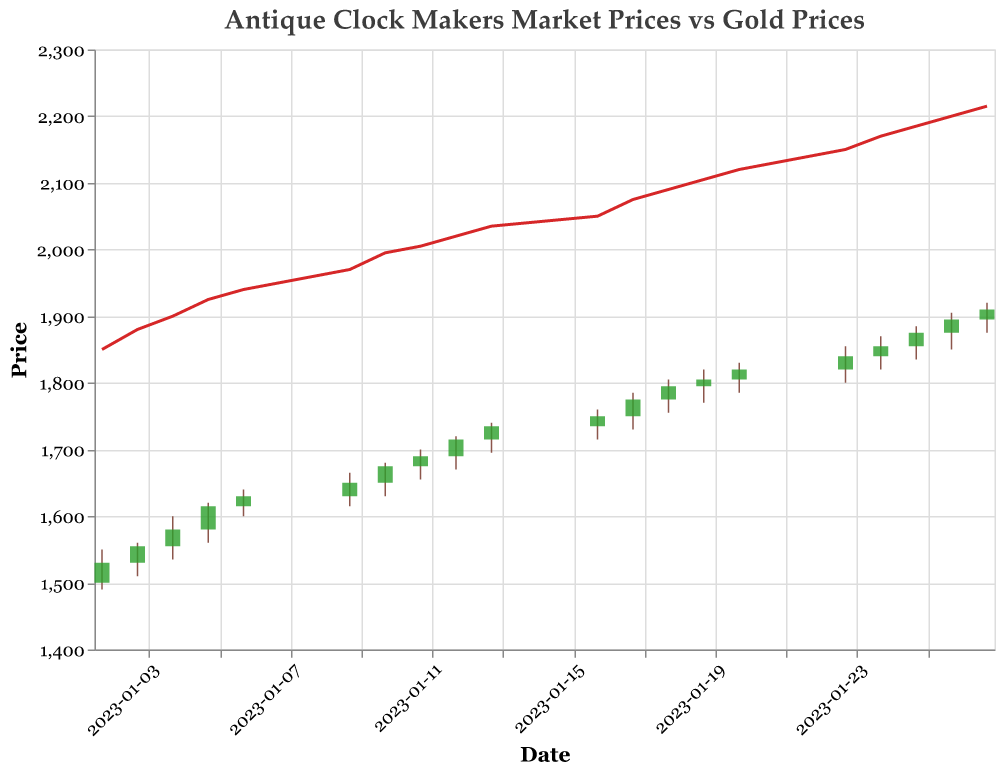How many trading days are represented in the figure? Count the number of unique dates for which data points are plotted. There are 20 rows of data, each representing a trading day.
Answer: 20 What does the line chart in the figure represent? The figure includes a line chart that corresponds to the "Gold_Price" field. This shows the trend of gold prices over the represented dates.
Answer: Gold prices On which date is the Market_High the highest? Review the 'Market_High' values for all dates and identify the maximum value. The highest 'Market_High' is 1920 on 2023-01-27.
Answer: 2023-01-27 What is the trend of the Gold_Price over the displayed period? Observe the line chart for the 'Gold_Price'. The gold price shows an increasing trend over time, starting from 1850 and ending at 2215.
Answer: Increasing How does the Market_Close value on 2023-01-27 compare to the Market_Close value on 2023-01-02? Locate the 'Market_Close' values for both dates. On 2023-01-27, the Market_Close is 1910, and on 2023-01-02, it is 1530. The value on 2023-01-27 is higher.
Answer: Higher What is the approximate difference between the highest and lowest Gold_Price in the given period? Identify the highest and lowest 'Gold_Price' values. The highest is 2215, and the lowest is 1850. Subtracting these gives a difference of 365.
Answer: 365 Did the Market_Close price ever exceed 1800 before 2023-01-19? Check the 'Market_Close' prices before 2023-01-19. The highest value before 2023-01-19 is 1795 on 2023-01-18, which is less than 1800.
Answer: No Which date had the closest Market_Open and Market_Close price? Calculate the absolute difference between 'Market_Open' and 'Market_Close' for each date and find the smallest difference. The smallest difference is 0 on 2023-01-06, giving the closest values.
Answer: 2023-01-06 